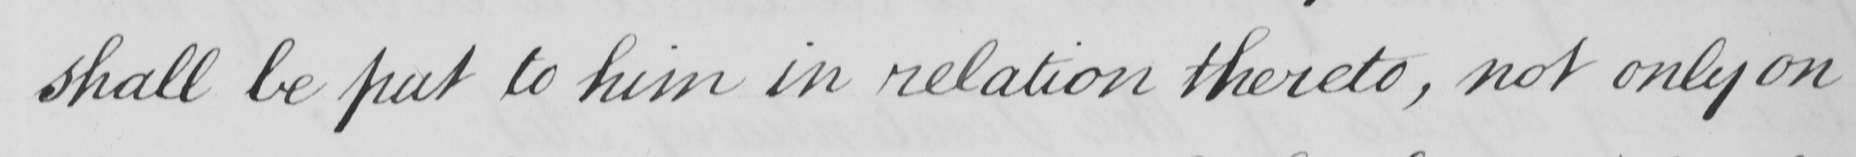What text is written in this handwritten line? shall be put to him in relation thereto , not only on 